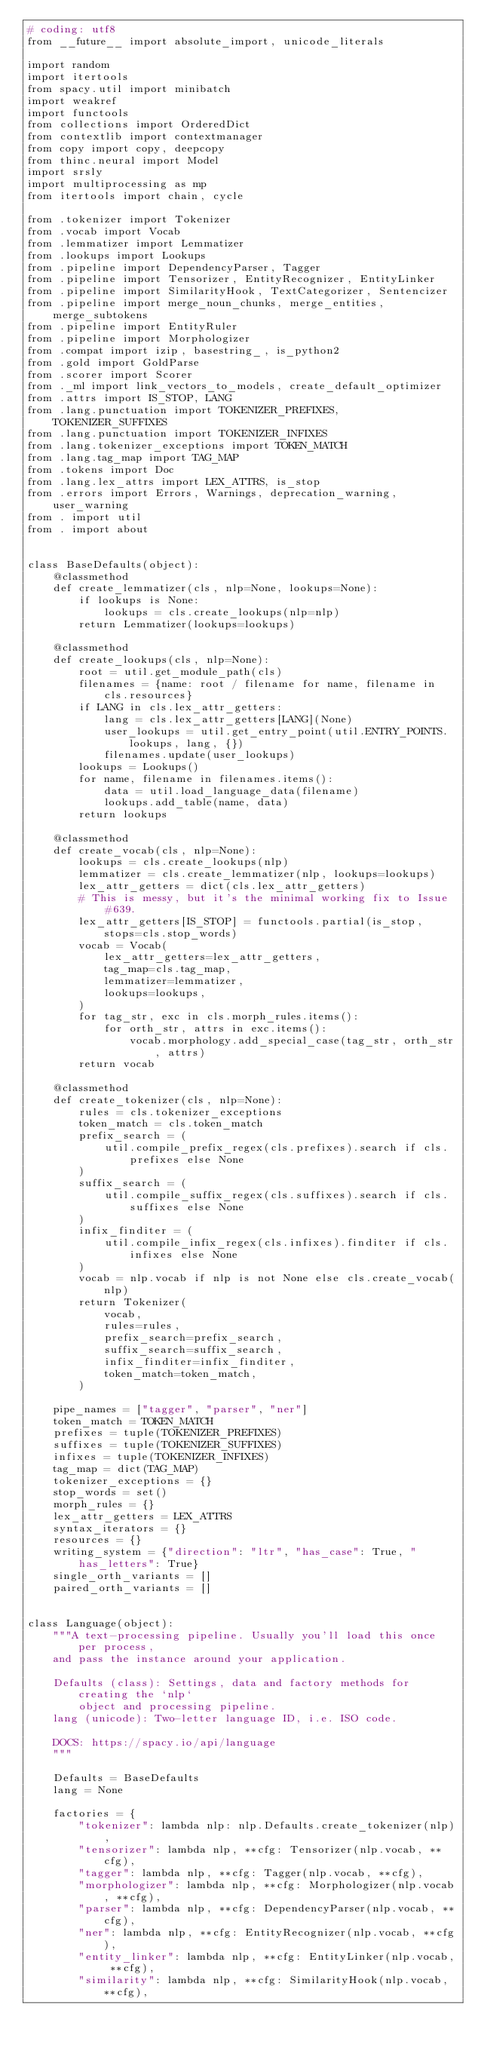<code> <loc_0><loc_0><loc_500><loc_500><_Python_># coding: utf8
from __future__ import absolute_import, unicode_literals

import random
import itertools
from spacy.util import minibatch
import weakref
import functools
from collections import OrderedDict
from contextlib import contextmanager
from copy import copy, deepcopy
from thinc.neural import Model
import srsly
import multiprocessing as mp
from itertools import chain, cycle

from .tokenizer import Tokenizer
from .vocab import Vocab
from .lemmatizer import Lemmatizer
from .lookups import Lookups
from .pipeline import DependencyParser, Tagger
from .pipeline import Tensorizer, EntityRecognizer, EntityLinker
from .pipeline import SimilarityHook, TextCategorizer, Sentencizer
from .pipeline import merge_noun_chunks, merge_entities, merge_subtokens
from .pipeline import EntityRuler
from .pipeline import Morphologizer
from .compat import izip, basestring_, is_python2
from .gold import GoldParse
from .scorer import Scorer
from ._ml import link_vectors_to_models, create_default_optimizer
from .attrs import IS_STOP, LANG
from .lang.punctuation import TOKENIZER_PREFIXES, TOKENIZER_SUFFIXES
from .lang.punctuation import TOKENIZER_INFIXES
from .lang.tokenizer_exceptions import TOKEN_MATCH
from .lang.tag_map import TAG_MAP
from .tokens import Doc
from .lang.lex_attrs import LEX_ATTRS, is_stop
from .errors import Errors, Warnings, deprecation_warning, user_warning
from . import util
from . import about


class BaseDefaults(object):
    @classmethod
    def create_lemmatizer(cls, nlp=None, lookups=None):
        if lookups is None:
            lookups = cls.create_lookups(nlp=nlp)
        return Lemmatizer(lookups=lookups)

    @classmethod
    def create_lookups(cls, nlp=None):
        root = util.get_module_path(cls)
        filenames = {name: root / filename for name, filename in cls.resources}
        if LANG in cls.lex_attr_getters:
            lang = cls.lex_attr_getters[LANG](None)
            user_lookups = util.get_entry_point(util.ENTRY_POINTS.lookups, lang, {})
            filenames.update(user_lookups)
        lookups = Lookups()
        for name, filename in filenames.items():
            data = util.load_language_data(filename)
            lookups.add_table(name, data)
        return lookups

    @classmethod
    def create_vocab(cls, nlp=None):
        lookups = cls.create_lookups(nlp)
        lemmatizer = cls.create_lemmatizer(nlp, lookups=lookups)
        lex_attr_getters = dict(cls.lex_attr_getters)
        # This is messy, but it's the minimal working fix to Issue #639.
        lex_attr_getters[IS_STOP] = functools.partial(is_stop, stops=cls.stop_words)
        vocab = Vocab(
            lex_attr_getters=lex_attr_getters,
            tag_map=cls.tag_map,
            lemmatizer=lemmatizer,
            lookups=lookups,
        )
        for tag_str, exc in cls.morph_rules.items():
            for orth_str, attrs in exc.items():
                vocab.morphology.add_special_case(tag_str, orth_str, attrs)
        return vocab

    @classmethod
    def create_tokenizer(cls, nlp=None):
        rules = cls.tokenizer_exceptions
        token_match = cls.token_match
        prefix_search = (
            util.compile_prefix_regex(cls.prefixes).search if cls.prefixes else None
        )
        suffix_search = (
            util.compile_suffix_regex(cls.suffixes).search if cls.suffixes else None
        )
        infix_finditer = (
            util.compile_infix_regex(cls.infixes).finditer if cls.infixes else None
        )
        vocab = nlp.vocab if nlp is not None else cls.create_vocab(nlp)
        return Tokenizer(
            vocab,
            rules=rules,
            prefix_search=prefix_search,
            suffix_search=suffix_search,
            infix_finditer=infix_finditer,
            token_match=token_match,
        )

    pipe_names = ["tagger", "parser", "ner"]
    token_match = TOKEN_MATCH
    prefixes = tuple(TOKENIZER_PREFIXES)
    suffixes = tuple(TOKENIZER_SUFFIXES)
    infixes = tuple(TOKENIZER_INFIXES)
    tag_map = dict(TAG_MAP)
    tokenizer_exceptions = {}
    stop_words = set()
    morph_rules = {}
    lex_attr_getters = LEX_ATTRS
    syntax_iterators = {}
    resources = {}
    writing_system = {"direction": "ltr", "has_case": True, "has_letters": True}
    single_orth_variants = []
    paired_orth_variants = []


class Language(object):
    """A text-processing pipeline. Usually you'll load this once per process,
    and pass the instance around your application.

    Defaults (class): Settings, data and factory methods for creating the `nlp`
        object and processing pipeline.
    lang (unicode): Two-letter language ID, i.e. ISO code.

    DOCS: https://spacy.io/api/language
    """

    Defaults = BaseDefaults
    lang = None

    factories = {
        "tokenizer": lambda nlp: nlp.Defaults.create_tokenizer(nlp),
        "tensorizer": lambda nlp, **cfg: Tensorizer(nlp.vocab, **cfg),
        "tagger": lambda nlp, **cfg: Tagger(nlp.vocab, **cfg),
        "morphologizer": lambda nlp, **cfg: Morphologizer(nlp.vocab, **cfg),
        "parser": lambda nlp, **cfg: DependencyParser(nlp.vocab, **cfg),
        "ner": lambda nlp, **cfg: EntityRecognizer(nlp.vocab, **cfg),
        "entity_linker": lambda nlp, **cfg: EntityLinker(nlp.vocab, **cfg),
        "similarity": lambda nlp, **cfg: SimilarityHook(nlp.vocab, **cfg),</code> 